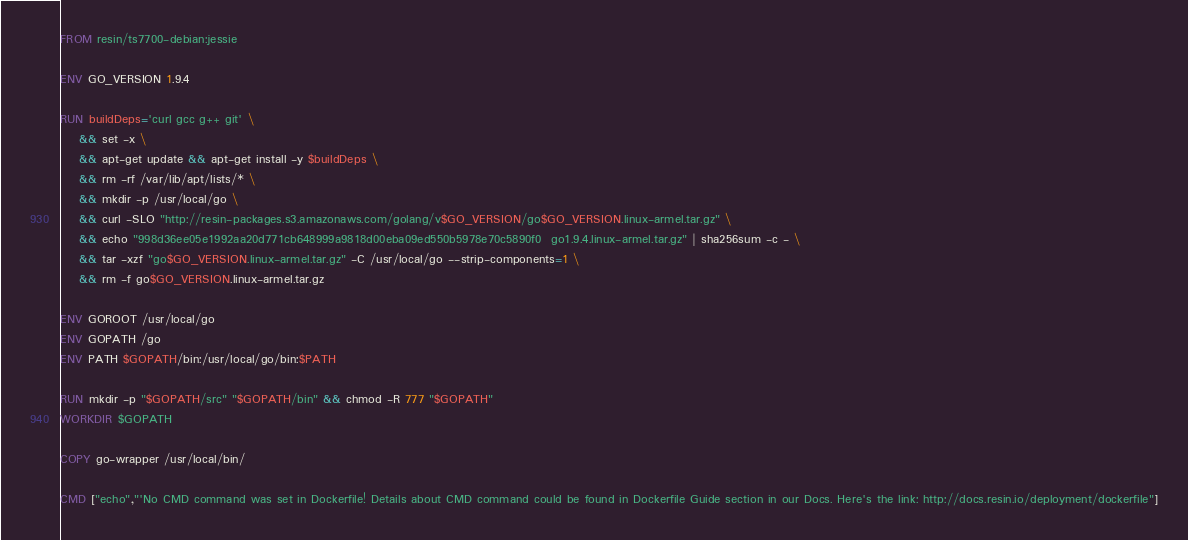<code> <loc_0><loc_0><loc_500><loc_500><_Dockerfile_>FROM resin/ts7700-debian:jessie

ENV GO_VERSION 1.9.4

RUN buildDeps='curl gcc g++ git' \
	&& set -x \
	&& apt-get update && apt-get install -y $buildDeps \
	&& rm -rf /var/lib/apt/lists/* \
	&& mkdir -p /usr/local/go \
	&& curl -SLO "http://resin-packages.s3.amazonaws.com/golang/v$GO_VERSION/go$GO_VERSION.linux-armel.tar.gz" \
	&& echo "998d36ee05e1992aa20d771cb648999a9818d00eba09ed550b5978e70c5890f0  go1.9.4.linux-armel.tar.gz" | sha256sum -c - \
	&& tar -xzf "go$GO_VERSION.linux-armel.tar.gz" -C /usr/local/go --strip-components=1 \
	&& rm -f go$GO_VERSION.linux-armel.tar.gz

ENV GOROOT /usr/local/go
ENV GOPATH /go
ENV PATH $GOPATH/bin:/usr/local/go/bin:$PATH

RUN mkdir -p "$GOPATH/src" "$GOPATH/bin" && chmod -R 777 "$GOPATH"
WORKDIR $GOPATH

COPY go-wrapper /usr/local/bin/

CMD ["echo","'No CMD command was set in Dockerfile! Details about CMD command could be found in Dockerfile Guide section in our Docs. Here's the link: http://docs.resin.io/deployment/dockerfile"]
</code> 